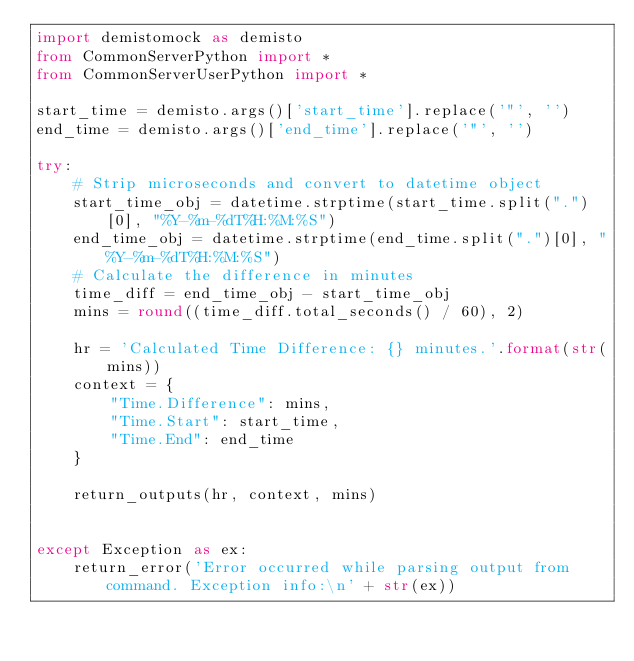Convert code to text. <code><loc_0><loc_0><loc_500><loc_500><_Python_>import demistomock as demisto
from CommonServerPython import *
from CommonServerUserPython import *

start_time = demisto.args()['start_time'].replace('"', '')
end_time = demisto.args()['end_time'].replace('"', '')

try:
    # Strip microseconds and convert to datetime object
    start_time_obj = datetime.strptime(start_time.split(".")[0], "%Y-%m-%dT%H:%M:%S")
    end_time_obj = datetime.strptime(end_time.split(".")[0], "%Y-%m-%dT%H:%M:%S")
    # Calculate the difference in minutes
    time_diff = end_time_obj - start_time_obj
    mins = round((time_diff.total_seconds() / 60), 2)

    hr = 'Calculated Time Difference: {} minutes.'.format(str(mins))
    context = {
        "Time.Difference": mins,
        "Time.Start": start_time,
        "Time.End": end_time
    }

    return_outputs(hr, context, mins)


except Exception as ex:
    return_error('Error occurred while parsing output from command. Exception info:\n' + str(ex))
</code> 